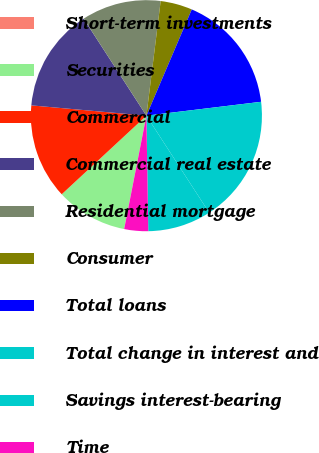<chart> <loc_0><loc_0><loc_500><loc_500><pie_chart><fcel>Short-term investments<fcel>Securities<fcel>Commercial<fcel>Commercial real estate<fcel>Residential mortgage<fcel>Consumer<fcel>Total loans<fcel>Total change in interest and<fcel>Savings interest-bearing<fcel>Time<nl><fcel>0.01%<fcel>10.0%<fcel>13.33%<fcel>14.44%<fcel>11.11%<fcel>4.45%<fcel>16.66%<fcel>17.77%<fcel>8.89%<fcel>3.34%<nl></chart> 